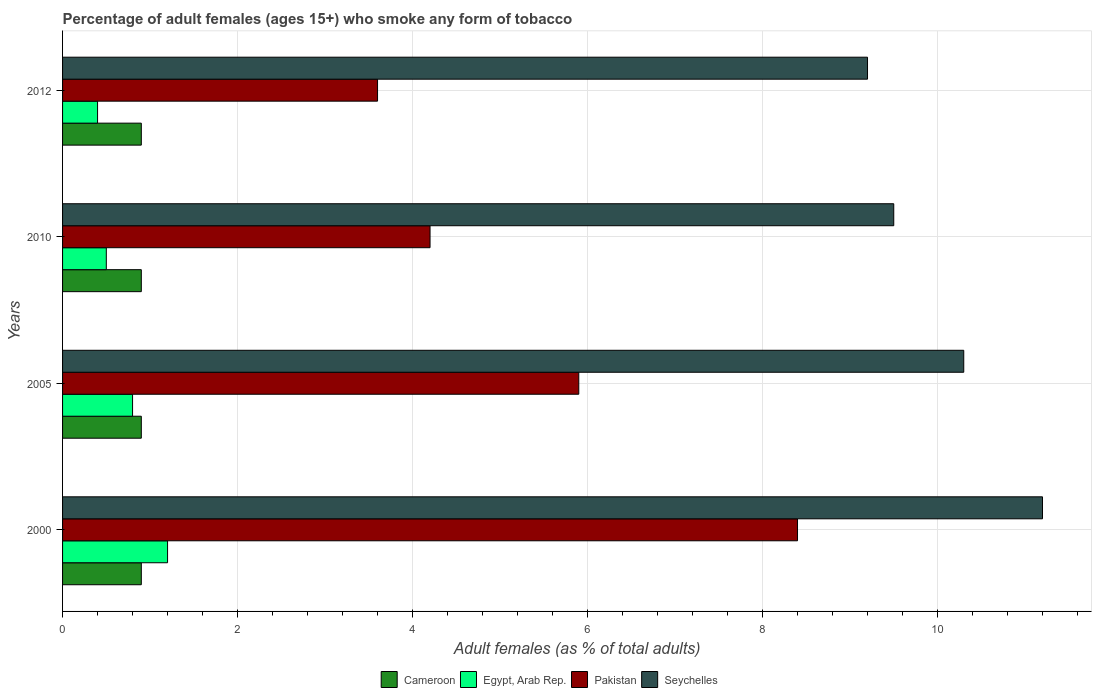How many groups of bars are there?
Offer a very short reply. 4. How many bars are there on the 3rd tick from the top?
Your answer should be compact. 4. How many bars are there on the 3rd tick from the bottom?
Provide a succinct answer. 4. What is the label of the 4th group of bars from the top?
Your response must be concise. 2000. Across all years, what is the maximum percentage of adult females who smoke in Seychelles?
Provide a short and direct response. 11.2. In which year was the percentage of adult females who smoke in Seychelles maximum?
Provide a short and direct response. 2000. What is the total percentage of adult females who smoke in Cameroon in the graph?
Give a very brief answer. 3.6. What is the difference between the percentage of adult females who smoke in Pakistan in 2000 and that in 2012?
Offer a very short reply. 4.8. What is the difference between the percentage of adult females who smoke in Seychelles in 2010 and the percentage of adult females who smoke in Cameroon in 2012?
Provide a succinct answer. 8.6. What is the average percentage of adult females who smoke in Seychelles per year?
Make the answer very short. 10.05. In the year 2005, what is the difference between the percentage of adult females who smoke in Egypt, Arab Rep. and percentage of adult females who smoke in Cameroon?
Make the answer very short. -0.1. In how many years, is the percentage of adult females who smoke in Egypt, Arab Rep. greater than 0.8 %?
Offer a terse response. 1. What is the ratio of the percentage of adult females who smoke in Cameroon in 2000 to that in 2010?
Provide a short and direct response. 1. Is the difference between the percentage of adult females who smoke in Egypt, Arab Rep. in 2000 and 2010 greater than the difference between the percentage of adult females who smoke in Cameroon in 2000 and 2010?
Your answer should be compact. Yes. What is the difference between the highest and the second highest percentage of adult females who smoke in Cameroon?
Provide a short and direct response. 0. What is the difference between the highest and the lowest percentage of adult females who smoke in Pakistan?
Your response must be concise. 4.8. In how many years, is the percentage of adult females who smoke in Egypt, Arab Rep. greater than the average percentage of adult females who smoke in Egypt, Arab Rep. taken over all years?
Your answer should be very brief. 2. What does the 1st bar from the bottom in 2010 represents?
Make the answer very short. Cameroon. Are all the bars in the graph horizontal?
Your answer should be very brief. Yes. How many years are there in the graph?
Provide a succinct answer. 4. Does the graph contain grids?
Provide a short and direct response. Yes. Where does the legend appear in the graph?
Give a very brief answer. Bottom center. How are the legend labels stacked?
Provide a short and direct response. Horizontal. What is the title of the graph?
Make the answer very short. Percentage of adult females (ages 15+) who smoke any form of tobacco. What is the label or title of the X-axis?
Make the answer very short. Adult females (as % of total adults). What is the label or title of the Y-axis?
Provide a short and direct response. Years. What is the Adult females (as % of total adults) in Egypt, Arab Rep. in 2000?
Your answer should be very brief. 1.2. What is the Adult females (as % of total adults) of Seychelles in 2000?
Your answer should be very brief. 11.2. What is the Adult females (as % of total adults) of Egypt, Arab Rep. in 2005?
Provide a short and direct response. 0.8. What is the Adult females (as % of total adults) in Pakistan in 2005?
Your answer should be compact. 5.9. What is the Adult females (as % of total adults) of Seychelles in 2005?
Your response must be concise. 10.3. What is the Adult females (as % of total adults) of Cameroon in 2010?
Keep it short and to the point. 0.9. What is the Adult females (as % of total adults) in Pakistan in 2010?
Ensure brevity in your answer.  4.2. What is the Adult females (as % of total adults) of Seychelles in 2010?
Ensure brevity in your answer.  9.5. What is the Adult females (as % of total adults) in Cameroon in 2012?
Keep it short and to the point. 0.9. What is the Adult females (as % of total adults) of Egypt, Arab Rep. in 2012?
Make the answer very short. 0.4. What is the Adult females (as % of total adults) of Seychelles in 2012?
Your answer should be very brief. 9.2. Across all years, what is the maximum Adult females (as % of total adults) in Egypt, Arab Rep.?
Ensure brevity in your answer.  1.2. Across all years, what is the maximum Adult females (as % of total adults) in Pakistan?
Give a very brief answer. 8.4. Across all years, what is the minimum Adult females (as % of total adults) in Seychelles?
Provide a succinct answer. 9.2. What is the total Adult females (as % of total adults) in Egypt, Arab Rep. in the graph?
Provide a short and direct response. 2.9. What is the total Adult females (as % of total adults) in Pakistan in the graph?
Give a very brief answer. 22.1. What is the total Adult females (as % of total adults) of Seychelles in the graph?
Give a very brief answer. 40.2. What is the difference between the Adult females (as % of total adults) in Cameroon in 2000 and that in 2005?
Offer a terse response. 0. What is the difference between the Adult females (as % of total adults) of Pakistan in 2000 and that in 2005?
Your answer should be very brief. 2.5. What is the difference between the Adult females (as % of total adults) of Seychelles in 2000 and that in 2005?
Ensure brevity in your answer.  0.9. What is the difference between the Adult females (as % of total adults) in Pakistan in 2000 and that in 2010?
Keep it short and to the point. 4.2. What is the difference between the Adult females (as % of total adults) of Egypt, Arab Rep. in 2000 and that in 2012?
Your answer should be very brief. 0.8. What is the difference between the Adult females (as % of total adults) of Pakistan in 2000 and that in 2012?
Your response must be concise. 4.8. What is the difference between the Adult females (as % of total adults) of Seychelles in 2005 and that in 2010?
Give a very brief answer. 0.8. What is the difference between the Adult females (as % of total adults) in Pakistan in 2005 and that in 2012?
Offer a very short reply. 2.3. What is the difference between the Adult females (as % of total adults) in Cameroon in 2010 and that in 2012?
Your response must be concise. 0. What is the difference between the Adult females (as % of total adults) in Seychelles in 2010 and that in 2012?
Make the answer very short. 0.3. What is the difference between the Adult females (as % of total adults) of Cameroon in 2000 and the Adult females (as % of total adults) of Egypt, Arab Rep. in 2005?
Provide a short and direct response. 0.1. What is the difference between the Adult females (as % of total adults) of Cameroon in 2000 and the Adult females (as % of total adults) of Pakistan in 2005?
Give a very brief answer. -5. What is the difference between the Adult females (as % of total adults) in Egypt, Arab Rep. in 2000 and the Adult females (as % of total adults) in Pakistan in 2005?
Give a very brief answer. -4.7. What is the difference between the Adult females (as % of total adults) in Egypt, Arab Rep. in 2000 and the Adult females (as % of total adults) in Seychelles in 2005?
Offer a terse response. -9.1. What is the difference between the Adult females (as % of total adults) in Cameroon in 2000 and the Adult females (as % of total adults) in Pakistan in 2010?
Keep it short and to the point. -3.3. What is the difference between the Adult females (as % of total adults) of Cameroon in 2000 and the Adult females (as % of total adults) of Seychelles in 2010?
Give a very brief answer. -8.6. What is the difference between the Adult females (as % of total adults) of Egypt, Arab Rep. in 2000 and the Adult females (as % of total adults) of Pakistan in 2010?
Provide a succinct answer. -3. What is the difference between the Adult females (as % of total adults) of Pakistan in 2000 and the Adult females (as % of total adults) of Seychelles in 2010?
Provide a succinct answer. -1.1. What is the difference between the Adult females (as % of total adults) in Cameroon in 2005 and the Adult females (as % of total adults) in Egypt, Arab Rep. in 2010?
Offer a terse response. 0.4. What is the difference between the Adult females (as % of total adults) of Cameroon in 2005 and the Adult females (as % of total adults) of Seychelles in 2010?
Make the answer very short. -8.6. What is the difference between the Adult females (as % of total adults) in Cameroon in 2005 and the Adult females (as % of total adults) in Egypt, Arab Rep. in 2012?
Your response must be concise. 0.5. What is the difference between the Adult females (as % of total adults) of Cameroon in 2005 and the Adult females (as % of total adults) of Pakistan in 2012?
Give a very brief answer. -2.7. What is the difference between the Adult females (as % of total adults) in Cameroon in 2005 and the Adult females (as % of total adults) in Seychelles in 2012?
Provide a short and direct response. -8.3. What is the difference between the Adult females (as % of total adults) of Egypt, Arab Rep. in 2005 and the Adult females (as % of total adults) of Seychelles in 2012?
Your answer should be very brief. -8.4. What is the difference between the Adult females (as % of total adults) in Cameroon in 2010 and the Adult females (as % of total adults) in Pakistan in 2012?
Ensure brevity in your answer.  -2.7. What is the difference between the Adult females (as % of total adults) of Egypt, Arab Rep. in 2010 and the Adult females (as % of total adults) of Pakistan in 2012?
Make the answer very short. -3.1. What is the average Adult females (as % of total adults) of Cameroon per year?
Provide a short and direct response. 0.9. What is the average Adult females (as % of total adults) in Egypt, Arab Rep. per year?
Ensure brevity in your answer.  0.72. What is the average Adult females (as % of total adults) of Pakistan per year?
Ensure brevity in your answer.  5.53. What is the average Adult females (as % of total adults) of Seychelles per year?
Provide a succinct answer. 10.05. In the year 2000, what is the difference between the Adult females (as % of total adults) in Cameroon and Adult females (as % of total adults) in Egypt, Arab Rep.?
Offer a very short reply. -0.3. In the year 2000, what is the difference between the Adult females (as % of total adults) of Cameroon and Adult females (as % of total adults) of Seychelles?
Provide a succinct answer. -10.3. In the year 2000, what is the difference between the Adult females (as % of total adults) in Egypt, Arab Rep. and Adult females (as % of total adults) in Seychelles?
Offer a terse response. -10. In the year 2005, what is the difference between the Adult females (as % of total adults) of Cameroon and Adult females (as % of total adults) of Seychelles?
Your answer should be compact. -9.4. In the year 2005, what is the difference between the Adult females (as % of total adults) of Egypt, Arab Rep. and Adult females (as % of total adults) of Pakistan?
Make the answer very short. -5.1. In the year 2005, what is the difference between the Adult females (as % of total adults) in Egypt, Arab Rep. and Adult females (as % of total adults) in Seychelles?
Your answer should be very brief. -9.5. In the year 2010, what is the difference between the Adult females (as % of total adults) of Cameroon and Adult females (as % of total adults) of Egypt, Arab Rep.?
Your response must be concise. 0.4. In the year 2010, what is the difference between the Adult females (as % of total adults) in Egypt, Arab Rep. and Adult females (as % of total adults) in Pakistan?
Your response must be concise. -3.7. In the year 2010, what is the difference between the Adult females (as % of total adults) of Pakistan and Adult females (as % of total adults) of Seychelles?
Provide a succinct answer. -5.3. In the year 2012, what is the difference between the Adult females (as % of total adults) of Cameroon and Adult females (as % of total adults) of Egypt, Arab Rep.?
Offer a very short reply. 0.5. In the year 2012, what is the difference between the Adult females (as % of total adults) of Egypt, Arab Rep. and Adult females (as % of total adults) of Pakistan?
Keep it short and to the point. -3.2. In the year 2012, what is the difference between the Adult females (as % of total adults) of Pakistan and Adult females (as % of total adults) of Seychelles?
Provide a short and direct response. -5.6. What is the ratio of the Adult females (as % of total adults) in Egypt, Arab Rep. in 2000 to that in 2005?
Offer a very short reply. 1.5. What is the ratio of the Adult females (as % of total adults) of Pakistan in 2000 to that in 2005?
Provide a short and direct response. 1.42. What is the ratio of the Adult females (as % of total adults) in Seychelles in 2000 to that in 2005?
Give a very brief answer. 1.09. What is the ratio of the Adult females (as % of total adults) of Cameroon in 2000 to that in 2010?
Ensure brevity in your answer.  1. What is the ratio of the Adult females (as % of total adults) in Seychelles in 2000 to that in 2010?
Provide a succinct answer. 1.18. What is the ratio of the Adult females (as % of total adults) in Cameroon in 2000 to that in 2012?
Offer a very short reply. 1. What is the ratio of the Adult females (as % of total adults) of Pakistan in 2000 to that in 2012?
Provide a succinct answer. 2.33. What is the ratio of the Adult females (as % of total adults) of Seychelles in 2000 to that in 2012?
Make the answer very short. 1.22. What is the ratio of the Adult females (as % of total adults) in Cameroon in 2005 to that in 2010?
Make the answer very short. 1. What is the ratio of the Adult females (as % of total adults) of Pakistan in 2005 to that in 2010?
Your answer should be compact. 1.4. What is the ratio of the Adult females (as % of total adults) of Seychelles in 2005 to that in 2010?
Provide a short and direct response. 1.08. What is the ratio of the Adult females (as % of total adults) of Egypt, Arab Rep. in 2005 to that in 2012?
Your response must be concise. 2. What is the ratio of the Adult females (as % of total adults) of Pakistan in 2005 to that in 2012?
Provide a short and direct response. 1.64. What is the ratio of the Adult females (as % of total adults) in Seychelles in 2005 to that in 2012?
Provide a succinct answer. 1.12. What is the ratio of the Adult females (as % of total adults) of Seychelles in 2010 to that in 2012?
Give a very brief answer. 1.03. What is the difference between the highest and the second highest Adult females (as % of total adults) of Egypt, Arab Rep.?
Give a very brief answer. 0.4. What is the difference between the highest and the second highest Adult females (as % of total adults) in Seychelles?
Your response must be concise. 0.9. 